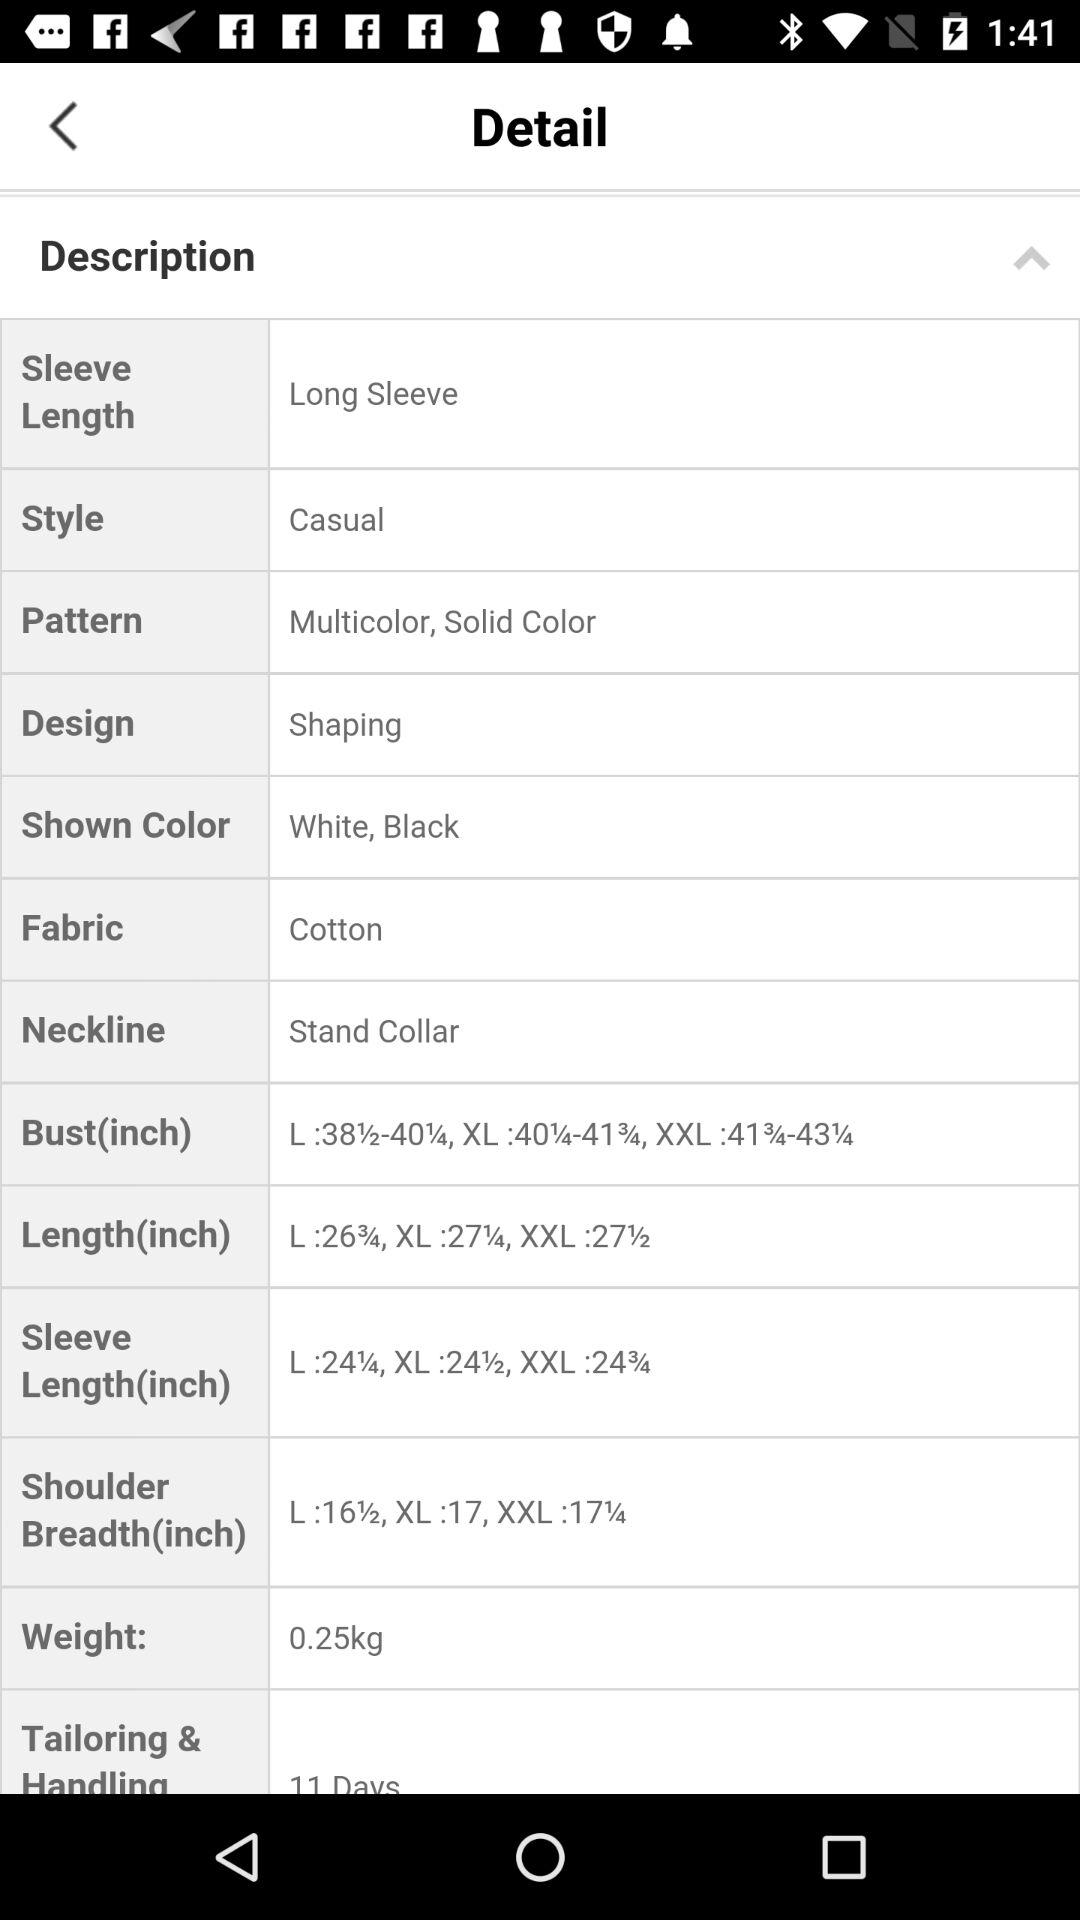What is the selected style? The selected style is casual. 